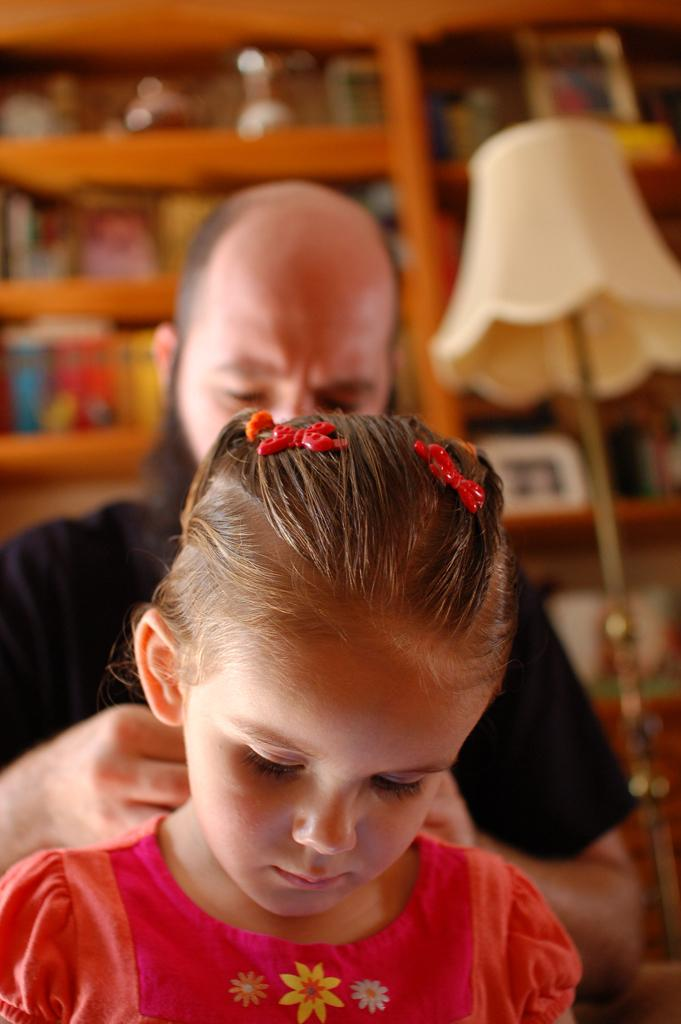Who is the main subject in the image? There is a girl in the image. Can you describe the person behind the girl? There is a person behind the girl, but their features are not clear due to the blurry background. What objects can be seen in the background of the image? There is a lamp and a cupboard with items in the background of the image. How would you describe the background of the image? The background is blurry. What type of hole can be seen in the girl's shirt in the image? There is no hole visible in the girl's shirt in the image. How does the girl answer the question asked by the person behind her? The image does not show any interaction between the girl and the person behind her, so it is not possible to determine how the girl answers any questions. 